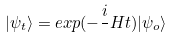<formula> <loc_0><loc_0><loc_500><loc_500>| \psi _ { t } \rangle = e x p ( - \frac { i } { } H t ) | \psi _ { o } \rangle</formula> 